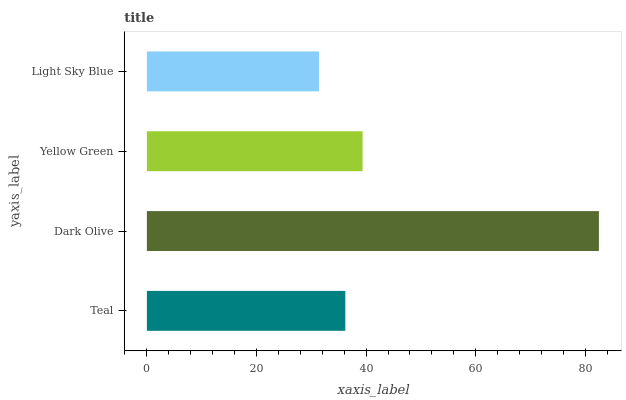Is Light Sky Blue the minimum?
Answer yes or no. Yes. Is Dark Olive the maximum?
Answer yes or no. Yes. Is Yellow Green the minimum?
Answer yes or no. No. Is Yellow Green the maximum?
Answer yes or no. No. Is Dark Olive greater than Yellow Green?
Answer yes or no. Yes. Is Yellow Green less than Dark Olive?
Answer yes or no. Yes. Is Yellow Green greater than Dark Olive?
Answer yes or no. No. Is Dark Olive less than Yellow Green?
Answer yes or no. No. Is Yellow Green the high median?
Answer yes or no. Yes. Is Teal the low median?
Answer yes or no. Yes. Is Light Sky Blue the high median?
Answer yes or no. No. Is Light Sky Blue the low median?
Answer yes or no. No. 